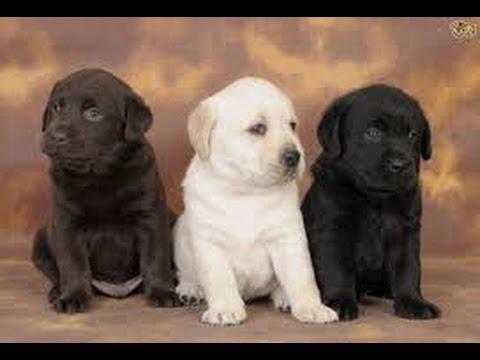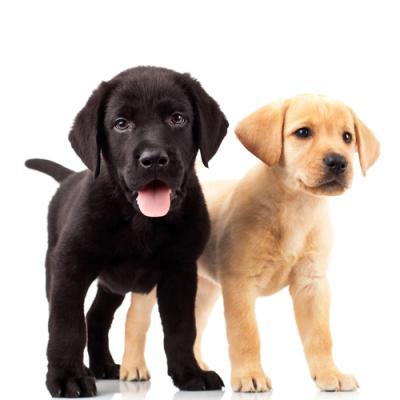The first image is the image on the left, the second image is the image on the right. Considering the images on both sides, is "Two tan dogs and a black dog pose together in the image on the right." valid? Answer yes or no. No. The first image is the image on the left, the second image is the image on the right. Analyze the images presented: Is the assertion "An image contains one black puppy to the left of one tan puppy, and contains only two puppies." valid? Answer yes or no. Yes. 